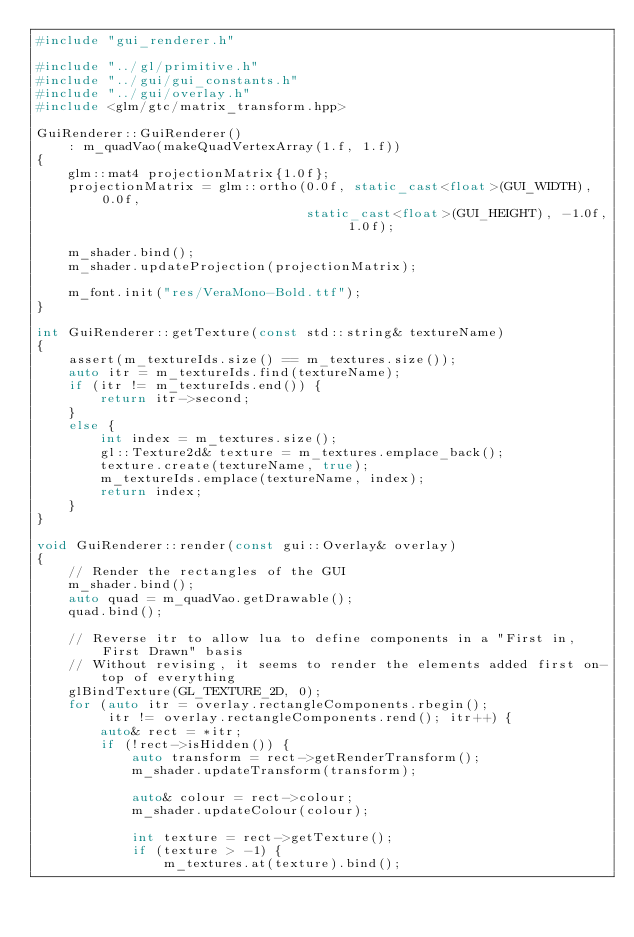<code> <loc_0><loc_0><loc_500><loc_500><_C++_>#include "gui_renderer.h"

#include "../gl/primitive.h"
#include "../gui/gui_constants.h"
#include "../gui/overlay.h"
#include <glm/gtc/matrix_transform.hpp>

GuiRenderer::GuiRenderer()
    : m_quadVao(makeQuadVertexArray(1.f, 1.f))
{
    glm::mat4 projectionMatrix{1.0f};
    projectionMatrix = glm::ortho(0.0f, static_cast<float>(GUI_WIDTH), 0.0f,
                                  static_cast<float>(GUI_HEIGHT), -1.0f, 1.0f);

    m_shader.bind();
    m_shader.updateProjection(projectionMatrix);

    m_font.init("res/VeraMono-Bold.ttf");
}

int GuiRenderer::getTexture(const std::string& textureName)
{
    assert(m_textureIds.size() == m_textures.size());
    auto itr = m_textureIds.find(textureName);
    if (itr != m_textureIds.end()) {
        return itr->second;
    }
    else {
        int index = m_textures.size();
        gl::Texture2d& texture = m_textures.emplace_back();
        texture.create(textureName, true);
        m_textureIds.emplace(textureName, index);
        return index;
    }
}

void GuiRenderer::render(const gui::Overlay& overlay)
{
    // Render the rectangles of the GUI
    m_shader.bind();
    auto quad = m_quadVao.getDrawable();
    quad.bind();

    // Reverse itr to allow lua to define components in a "First in, First Drawn" basis
    // Without revising, it seems to render the elements added first on-top of everything
    glBindTexture(GL_TEXTURE_2D, 0);
    for (auto itr = overlay.rectangleComponents.rbegin();
         itr != overlay.rectangleComponents.rend(); itr++) {
        auto& rect = *itr;
        if (!rect->isHidden()) {
            auto transform = rect->getRenderTransform();
            m_shader.updateTransform(transform);

            auto& colour = rect->colour;
            m_shader.updateColour(colour);

            int texture = rect->getTexture();
            if (texture > -1) {
                m_textures.at(texture).bind();</code> 